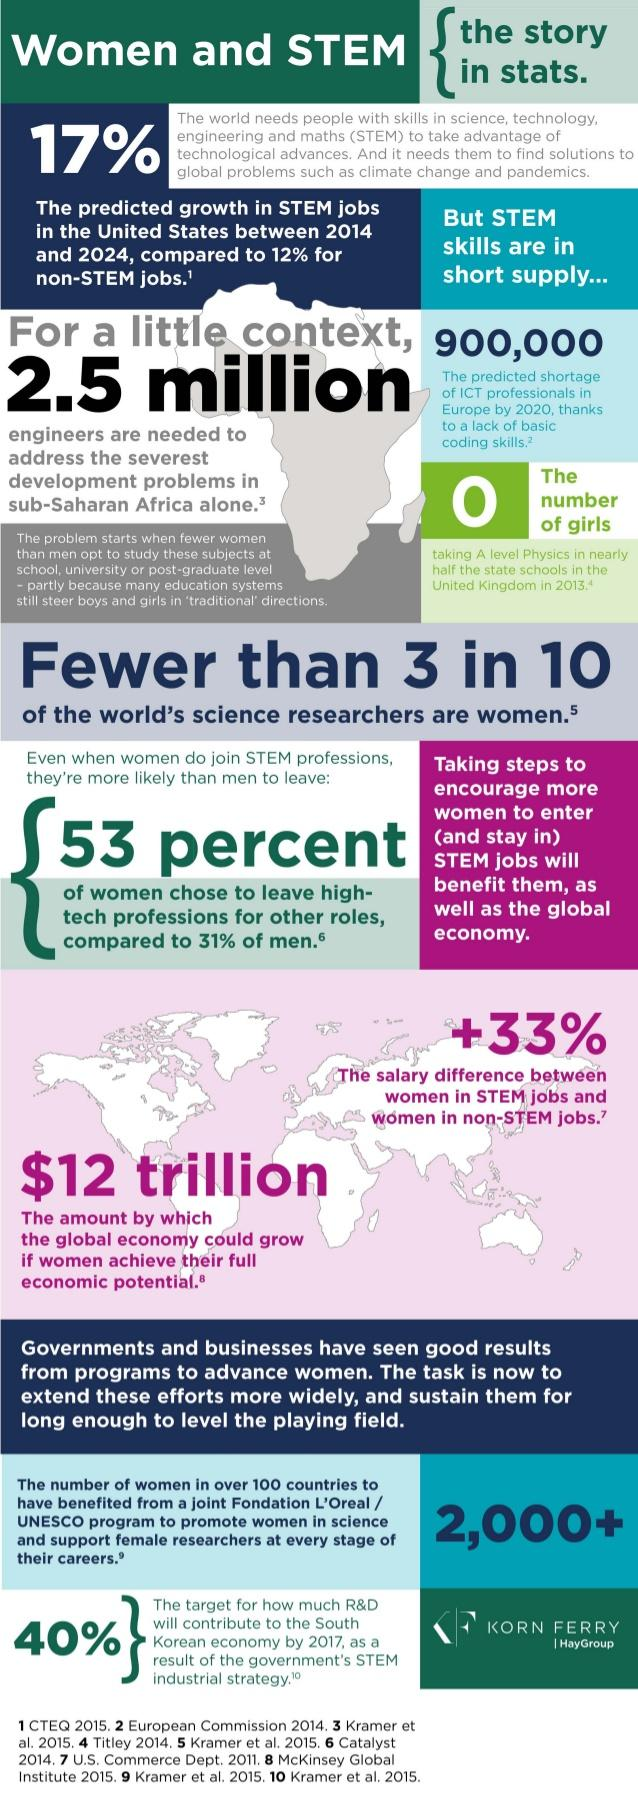List a handful of essential elements in this visual. The Fondation L'Oreal and UNESCO program will benefit more than 2,000 women in over 100 countries. The predicted shortage of ICT professionals in Europe by 2020 is expected to be approximately 900,000. 